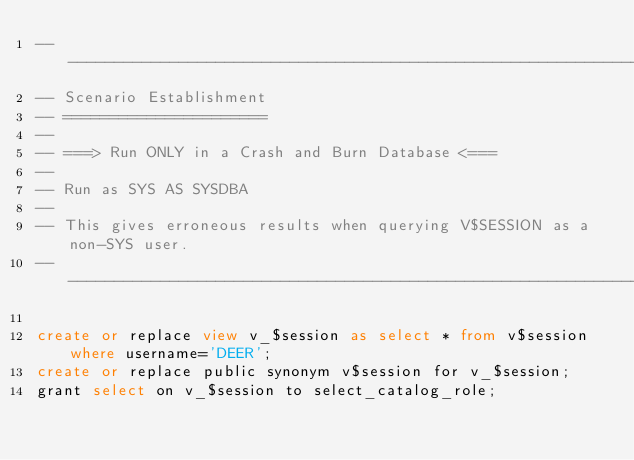Convert code to text. <code><loc_0><loc_0><loc_500><loc_500><_SQL_>-- -----------------------------------------------------------------------------
-- Scenario Establishment
-- ======================
--
-- ===> Run ONLY in a Crash and Burn Database <===
--
-- Run as SYS AS SYSDBA
--
-- This gives erroneous results when querying V$SESSION as a non-SYS user.
-- -----------------------------------------------------------------------------

create or replace view v_$session as select * from v$session where username='DEER';
create or replace public synonym v$session for v_$session;
grant select on v_$session to select_catalog_role;
</code> 